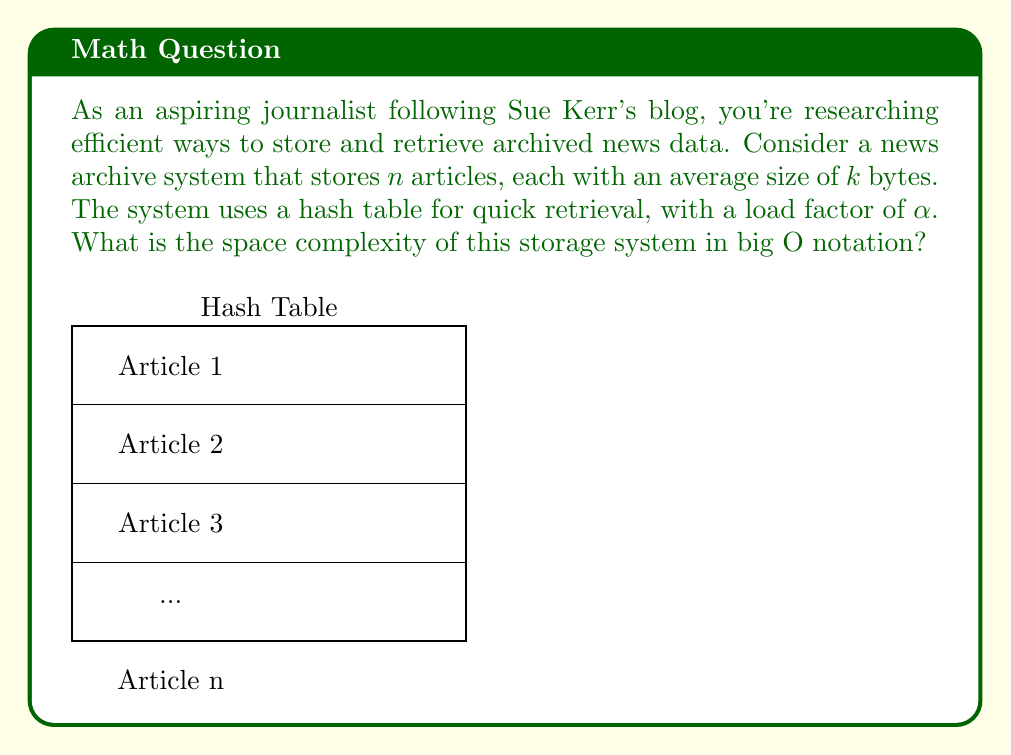Can you solve this math problem? Let's break this down step-by-step:

1) First, we need to consider the space taken by the articles themselves:
   - There are $n$ articles
   - Each article has an average size of $k$ bytes
   - Total space for articles: $n * k$ bytes

2) Now, let's consider the hash table:
   - The hash table is used for quick retrieval
   - The load factor $\alpha$ represents the ratio of occupied slots to the total slots
   - Number of slots in the hash table = $n / \alpha$

3) Each slot in the hash table typically stores a pointer or reference to the actual article data:
   - Assuming a pointer size of $c$ bytes (constant)
   - Space for hash table: $(n / \alpha) * c$ bytes

4) The total space complexity is the sum of these two components:
   $$ \text{Total Space} = nk + (n / \alpha) * c $$

5) Simplifying:
   $$ \text{Total Space} = n(k + c/\alpha) $$

6) In big O notation, we drop constant factors and lower-order terms:
   $$ O(n) $$

The space complexity is linear with respect to the number of articles, regardless of their individual sizes or the hash table's load factor.
Answer: $O(n)$ 